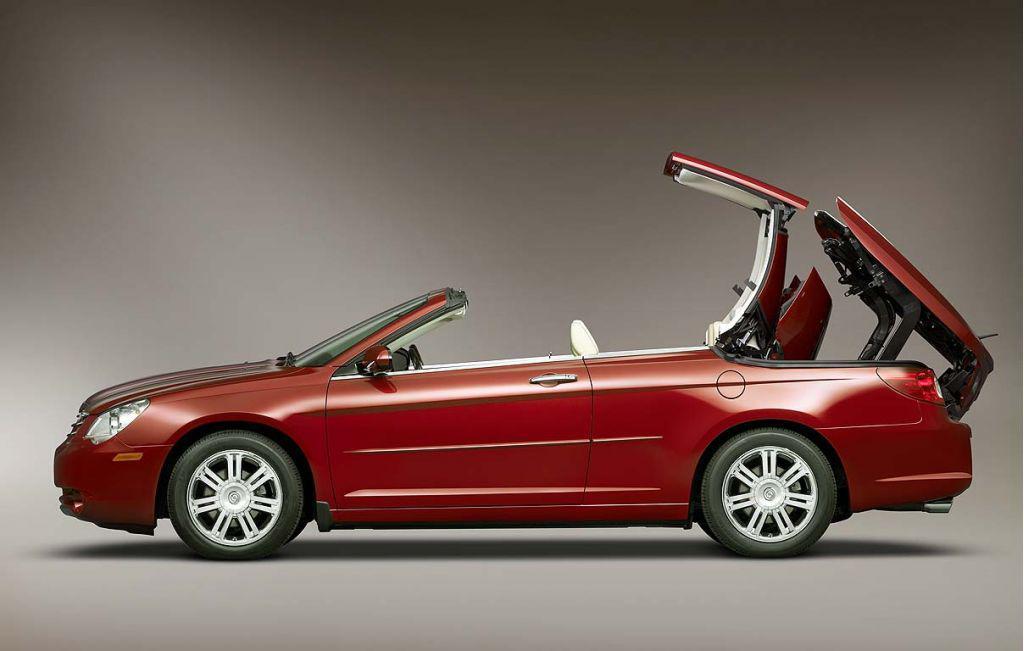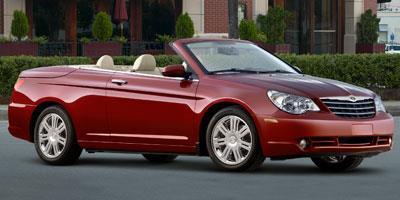The first image is the image on the left, the second image is the image on the right. Evaluate the accuracy of this statement regarding the images: "Both images contain a red convertible automobile.". Is it true? Answer yes or no. Yes. 